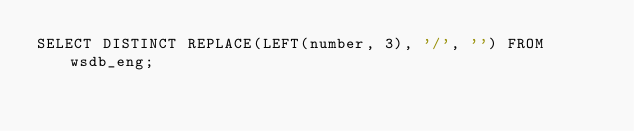Convert code to text. <code><loc_0><loc_0><loc_500><loc_500><_SQL_>SELECT DISTINCT REPLACE(LEFT(number, 3), '/', '') FROM wsdb_eng;
</code> 